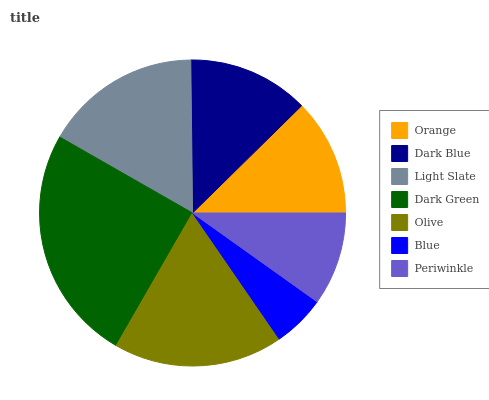Is Blue the minimum?
Answer yes or no. Yes. Is Dark Green the maximum?
Answer yes or no. Yes. Is Dark Blue the minimum?
Answer yes or no. No. Is Dark Blue the maximum?
Answer yes or no. No. Is Dark Blue greater than Orange?
Answer yes or no. Yes. Is Orange less than Dark Blue?
Answer yes or no. Yes. Is Orange greater than Dark Blue?
Answer yes or no. No. Is Dark Blue less than Orange?
Answer yes or no. No. Is Dark Blue the high median?
Answer yes or no. Yes. Is Dark Blue the low median?
Answer yes or no. Yes. Is Light Slate the high median?
Answer yes or no. No. Is Olive the low median?
Answer yes or no. No. 